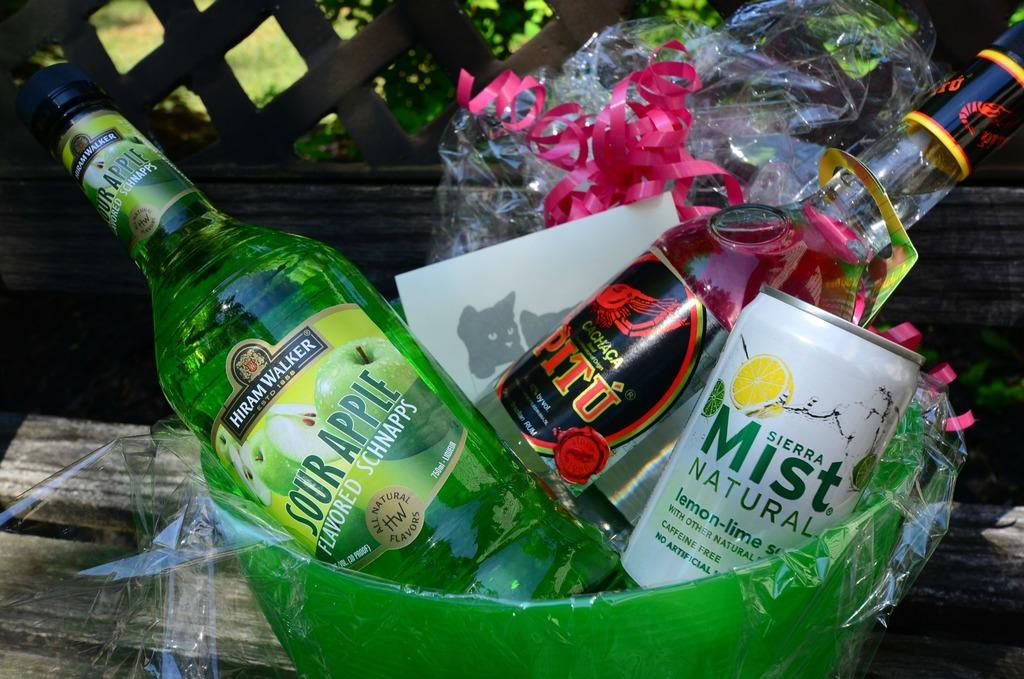<image>
Write a terse but informative summary of the picture. a gift basket has been made with sierra mist and alcohol 